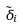<formula> <loc_0><loc_0><loc_500><loc_500>\tilde { \delta } _ { i }</formula> 